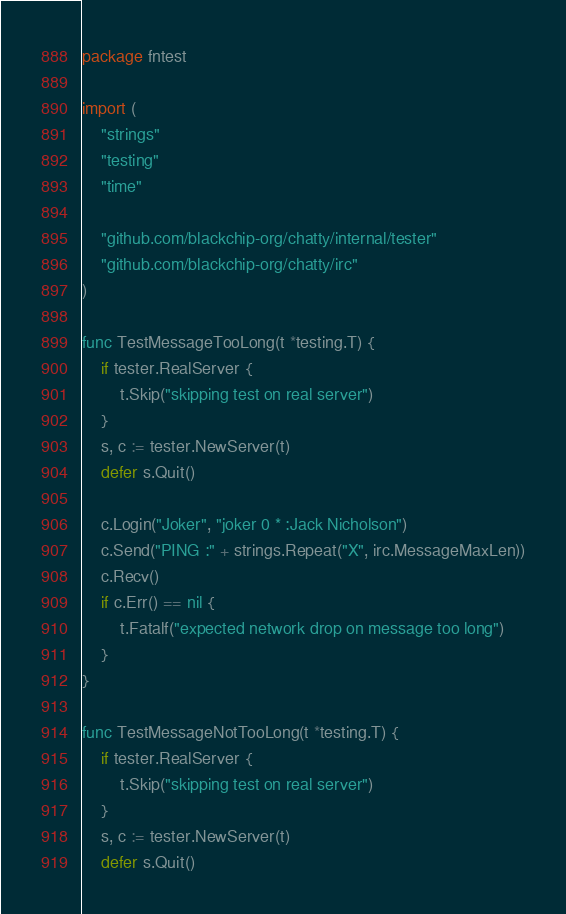<code> <loc_0><loc_0><loc_500><loc_500><_Go_>package fntest

import (
	"strings"
	"testing"
	"time"

	"github.com/blackchip-org/chatty/internal/tester"
	"github.com/blackchip-org/chatty/irc"
)

func TestMessageTooLong(t *testing.T) {
	if tester.RealServer {
		t.Skip("skipping test on real server")
	}
	s, c := tester.NewServer(t)
	defer s.Quit()

	c.Login("Joker", "joker 0 * :Jack Nicholson")
	c.Send("PING :" + strings.Repeat("X", irc.MessageMaxLen))
	c.Recv()
	if c.Err() == nil {
		t.Fatalf("expected network drop on message too long")
	}
}

func TestMessageNotTooLong(t *testing.T) {
	if tester.RealServer {
		t.Skip("skipping test on real server")
	}
	s, c := tester.NewServer(t)
	defer s.Quit()
</code> 